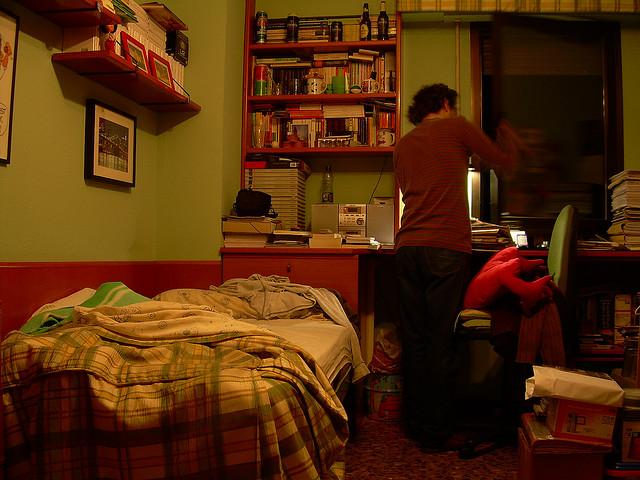What is in the room? Please explain your reasoning. bed. The room has a bed. 